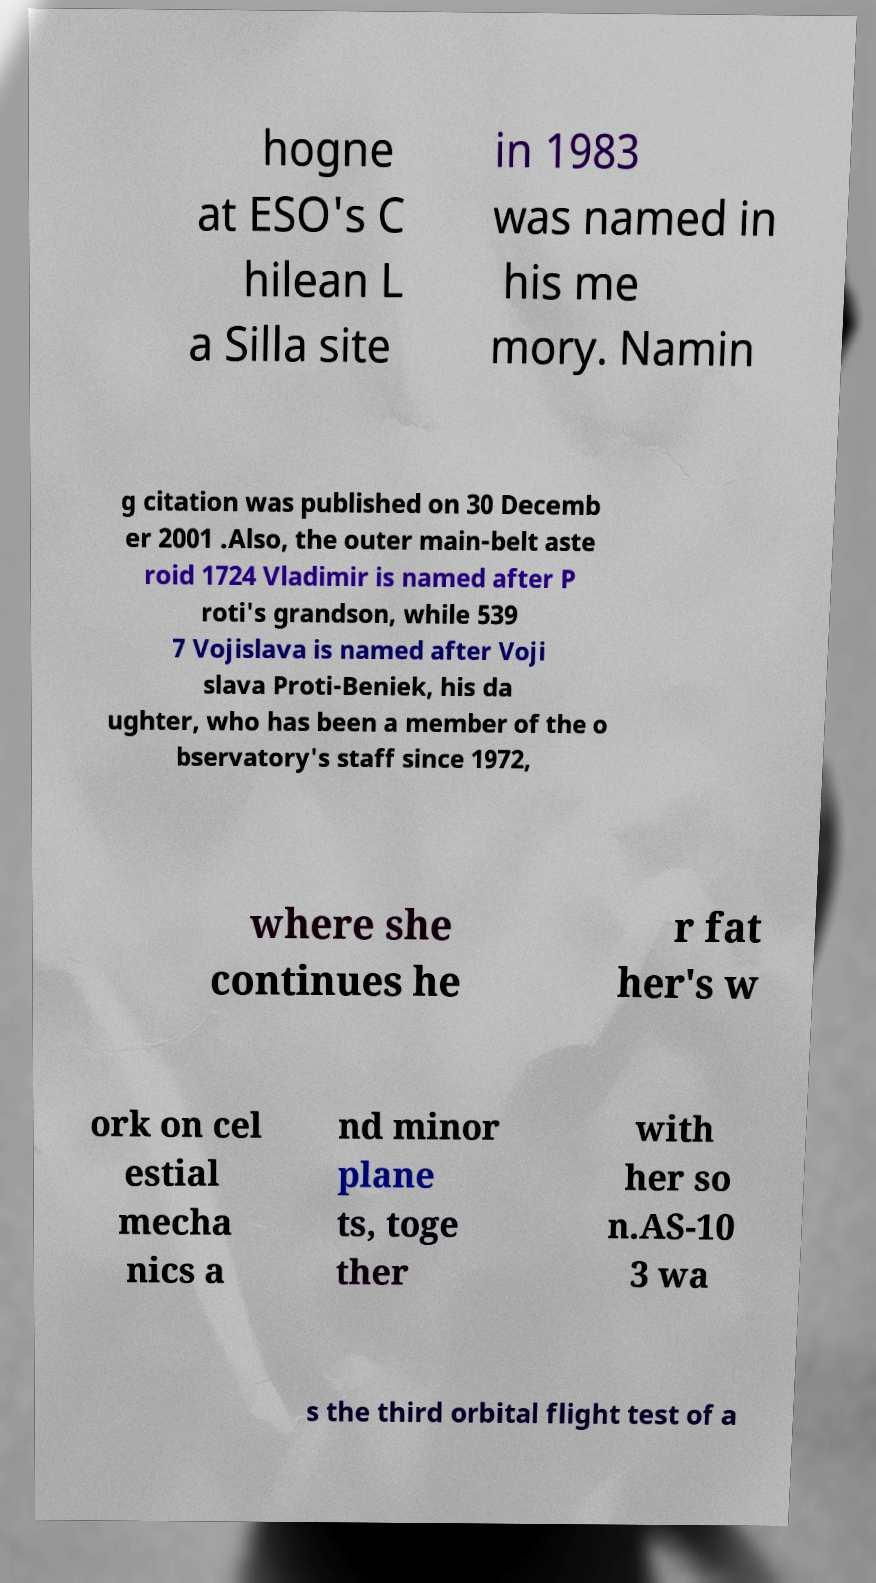Can you accurately transcribe the text from the provided image for me? hogne at ESO's C hilean L a Silla site in 1983 was named in his me mory. Namin g citation was published on 30 Decemb er 2001 .Also, the outer main-belt aste roid 1724 Vladimir is named after P roti's grandson, while 539 7 Vojislava is named after Voji slava Proti-Beniek, his da ughter, who has been a member of the o bservatory's staff since 1972, where she continues he r fat her's w ork on cel estial mecha nics a nd minor plane ts, toge ther with her so n.AS-10 3 wa s the third orbital flight test of a 